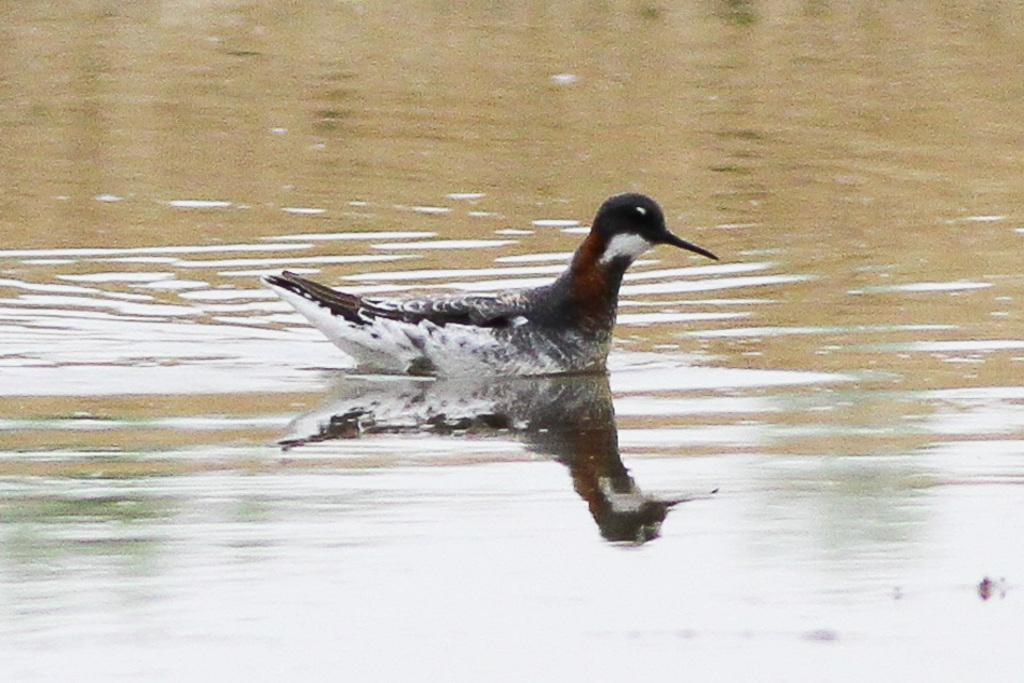What type of animal is in the image? There is a bird in the image. Can you describe the colors of the bird? The bird has white, black, and brown colors. Where is the bird located in the image? The bird is in the water. What type of dog can be seen swimming in the water with the bird? There is no dog present in the image; it only features a bird in the water. 